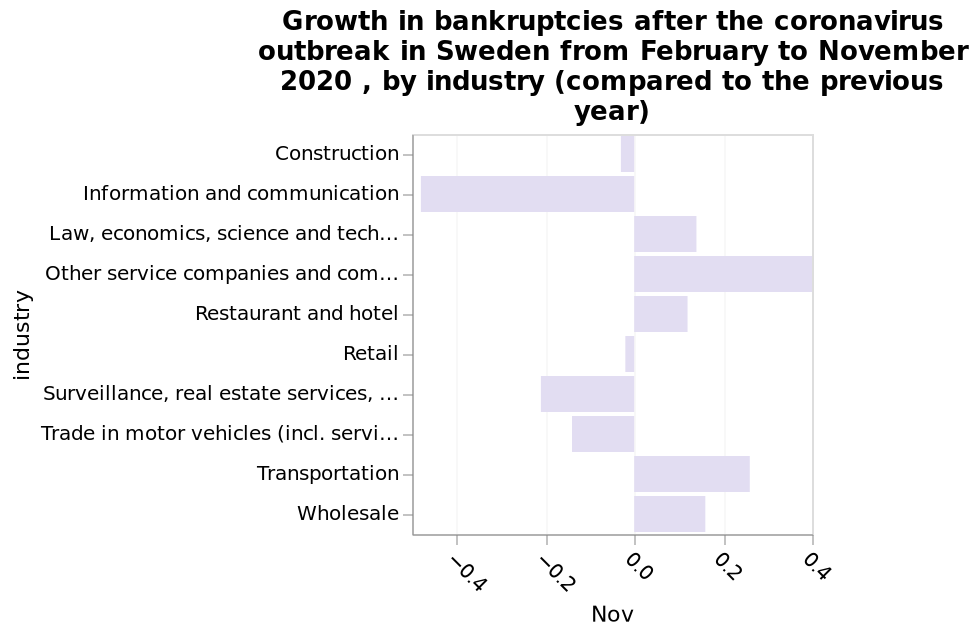<image>
What does the x-axis represent in the bar diagram?  The x-axis represents the month of November. What time period does the bar diagram cover? The bar diagram covers the time period from February to November 2020. please describe the details of the chart Here a is a bar diagram called Growth in bankruptcies after the coronavirus outbreak in Sweden from February to November 2020 , by industry (compared to the previous year). The x-axis shows Nov. There is a categorical scale from Construction to Wholesale on the y-axis, marked industry. Which industry is represented by the highest bar in the diagram? Without specific data points, we cannot determine which industry has the highest bar in the diagram. 